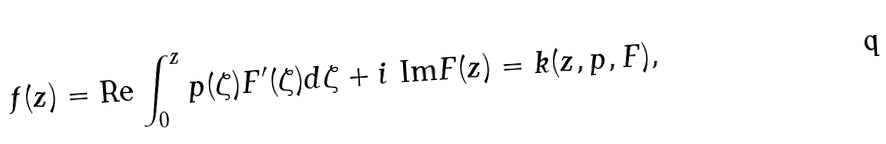Convert formula to latex. <formula><loc_0><loc_0><loc_500><loc_500>f ( z ) = \text {Re} \int _ { 0 } ^ { z } p ( \zeta ) F ^ { \prime } ( \zeta ) d \zeta + i \ \text {Im} F ( z ) = k ( z , p , F ) ,</formula> 